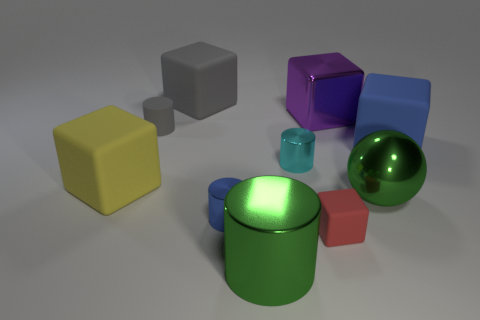What color is the large cylinder that is the same material as the green ball?
Provide a short and direct response. Green. There is a gray object that is behind the gray matte cylinder; are there any big yellow blocks that are on the right side of it?
Ensure brevity in your answer.  No. How many other objects are the same shape as the yellow matte object?
Provide a short and direct response. 4. Does the blue object in front of the small cyan cylinder have the same shape as the tiny matte object that is to the right of the tiny gray cylinder?
Ensure brevity in your answer.  No. How many small red matte blocks are on the right side of the rubber object that is behind the small rubber object on the left side of the cyan cylinder?
Give a very brief answer. 1. The large metallic block is what color?
Offer a very short reply. Purple. How many other objects are the same size as the blue matte cube?
Ensure brevity in your answer.  5. There is a green thing that is the same shape as the tiny gray thing; what is it made of?
Offer a terse response. Metal. What material is the blue thing in front of the cube to the left of the rubber block behind the purple object made of?
Give a very brief answer. Metal. There is a blue object that is made of the same material as the yellow thing; what size is it?
Keep it short and to the point. Large. 